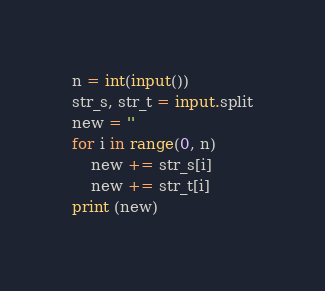<code> <loc_0><loc_0><loc_500><loc_500><_Python_>n = int(input())
str_s, str_t = input.split
new = ''
for i in range(0, n)
	new += str_s[i]
  	new += str_t[i]
print (new)</code> 